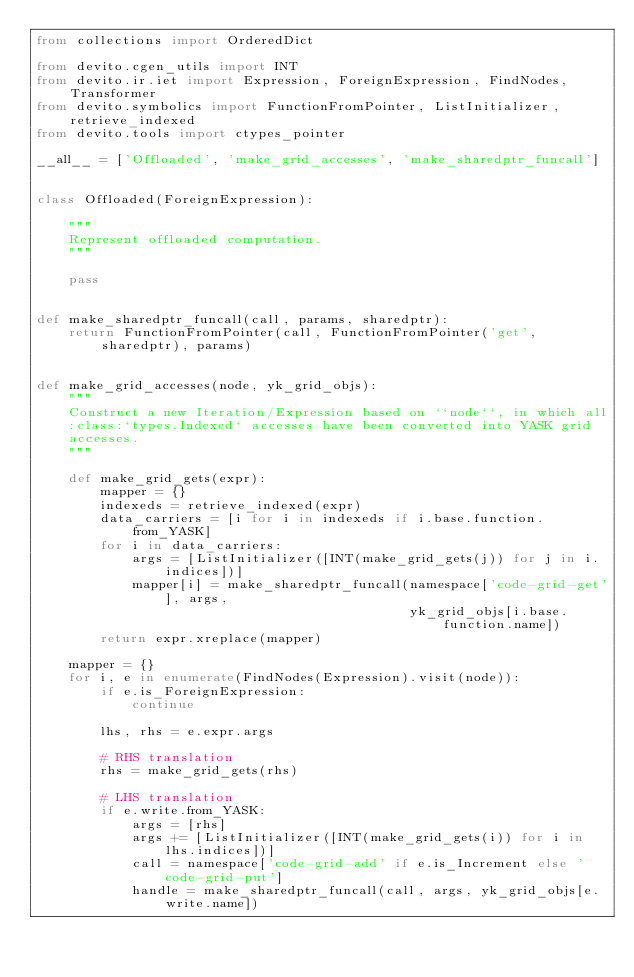Convert code to text. <code><loc_0><loc_0><loc_500><loc_500><_Python_>from collections import OrderedDict

from devito.cgen_utils import INT
from devito.ir.iet import Expression, ForeignExpression, FindNodes, Transformer
from devito.symbolics import FunctionFromPointer, ListInitializer, retrieve_indexed
from devito.tools import ctypes_pointer

__all__ = ['Offloaded', 'make_grid_accesses', 'make_sharedptr_funcall']


class Offloaded(ForeignExpression):

    """
    Represent offloaded computation.
    """

    pass


def make_sharedptr_funcall(call, params, sharedptr):
    return FunctionFromPointer(call, FunctionFromPointer('get', sharedptr), params)


def make_grid_accesses(node, yk_grid_objs):
    """
    Construct a new Iteration/Expression based on ``node``, in which all
    :class:`types.Indexed` accesses have been converted into YASK grid
    accesses.
    """

    def make_grid_gets(expr):
        mapper = {}
        indexeds = retrieve_indexed(expr)
        data_carriers = [i for i in indexeds if i.base.function.from_YASK]
        for i in data_carriers:
            args = [ListInitializer([INT(make_grid_gets(j)) for j in i.indices])]
            mapper[i] = make_sharedptr_funcall(namespace['code-grid-get'], args,
                                               yk_grid_objs[i.base.function.name])
        return expr.xreplace(mapper)

    mapper = {}
    for i, e in enumerate(FindNodes(Expression).visit(node)):
        if e.is_ForeignExpression:
            continue

        lhs, rhs = e.expr.args

        # RHS translation
        rhs = make_grid_gets(rhs)

        # LHS translation
        if e.write.from_YASK:
            args = [rhs]
            args += [ListInitializer([INT(make_grid_gets(i)) for i in lhs.indices])]
            call = namespace['code-grid-add' if e.is_Increment else 'code-grid-put']
            handle = make_sharedptr_funcall(call, args, yk_grid_objs[e.write.name])</code> 